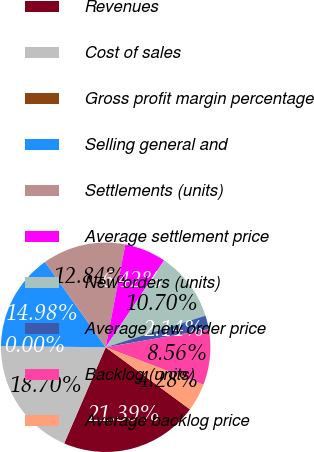Convert chart to OTSL. <chart><loc_0><loc_0><loc_500><loc_500><pie_chart><fcel>Revenues<fcel>Cost of sales<fcel>Gross profit margin percentage<fcel>Selling general and<fcel>Settlements (units)<fcel>Average settlement price<fcel>New orders (units)<fcel>Average new order price<fcel>Backlog (units)<fcel>Average backlog price<nl><fcel>21.39%<fcel>18.7%<fcel>0.0%<fcel>14.98%<fcel>12.84%<fcel>6.42%<fcel>10.7%<fcel>2.14%<fcel>8.56%<fcel>4.28%<nl></chart> 